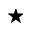Convert formula to latex. <formula><loc_0><loc_0><loc_500><loc_500>^ { * }</formula> 